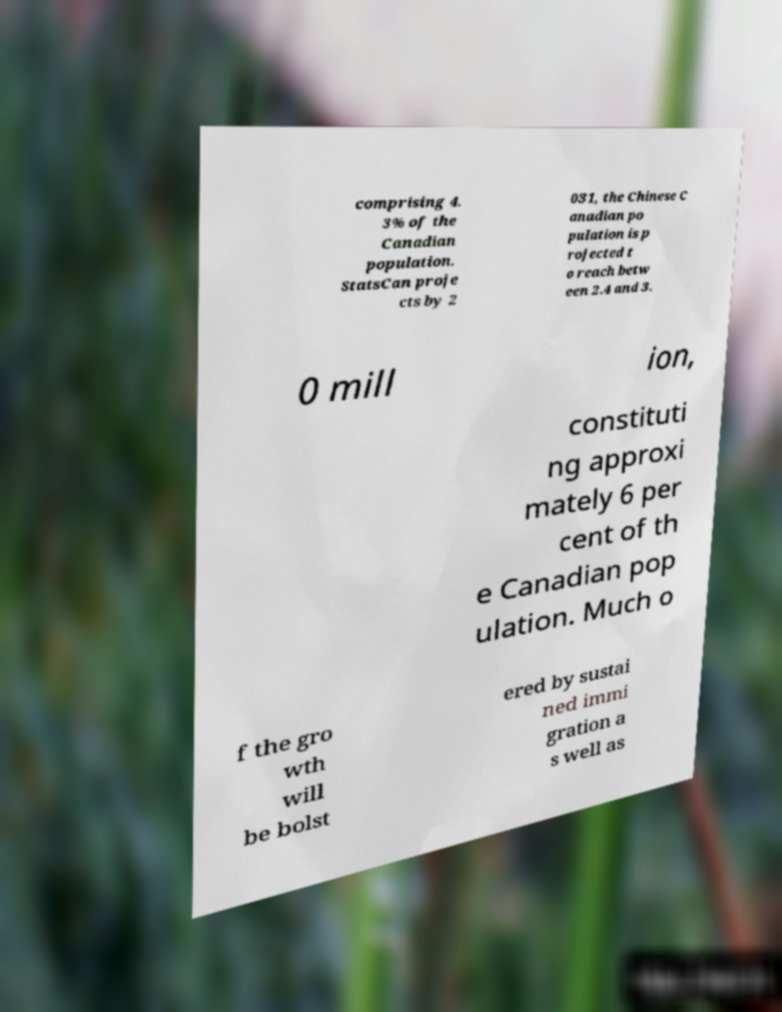There's text embedded in this image that I need extracted. Can you transcribe it verbatim? comprising 4. 3% of the Canadian population. StatsCan proje cts by 2 031, the Chinese C anadian po pulation is p rojected t o reach betw een 2.4 and 3. 0 mill ion, constituti ng approxi mately 6 per cent of th e Canadian pop ulation. Much o f the gro wth will be bolst ered by sustai ned immi gration a s well as 